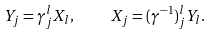<formula> <loc_0><loc_0><loc_500><loc_500>Y _ { j } = \gamma ^ { l } _ { j } X _ { l } , \quad X _ { j } = ( \gamma ^ { - 1 } ) ^ { l } _ { j } Y _ { l } .</formula> 